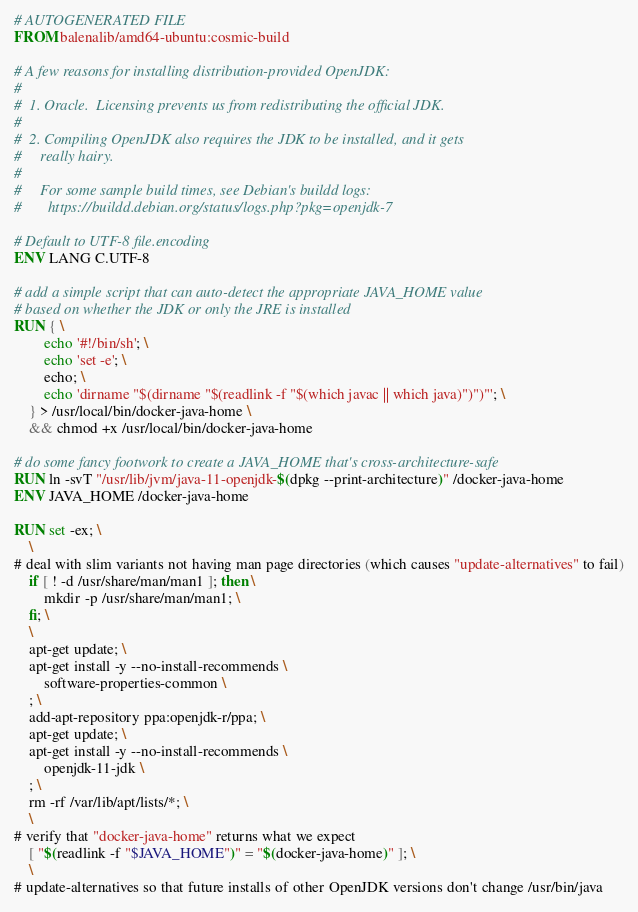<code> <loc_0><loc_0><loc_500><loc_500><_Dockerfile_># AUTOGENERATED FILE
FROM balenalib/amd64-ubuntu:cosmic-build

# A few reasons for installing distribution-provided OpenJDK:
#
#  1. Oracle.  Licensing prevents us from redistributing the official JDK.
#
#  2. Compiling OpenJDK also requires the JDK to be installed, and it gets
#     really hairy.
#
#     For some sample build times, see Debian's buildd logs:
#       https://buildd.debian.org/status/logs.php?pkg=openjdk-7

# Default to UTF-8 file.encoding
ENV LANG C.UTF-8

# add a simple script that can auto-detect the appropriate JAVA_HOME value
# based on whether the JDK or only the JRE is installed
RUN { \
		echo '#!/bin/sh'; \
		echo 'set -e'; \
		echo; \
		echo 'dirname "$(dirname "$(readlink -f "$(which javac || which java)")")"'; \
	} > /usr/local/bin/docker-java-home \
	&& chmod +x /usr/local/bin/docker-java-home

# do some fancy footwork to create a JAVA_HOME that's cross-architecture-safe
RUN ln -svT "/usr/lib/jvm/java-11-openjdk-$(dpkg --print-architecture)" /docker-java-home
ENV JAVA_HOME /docker-java-home

RUN set -ex; \
	\
# deal with slim variants not having man page directories (which causes "update-alternatives" to fail)
	if [ ! -d /usr/share/man/man1 ]; then \
		mkdir -p /usr/share/man/man1; \
	fi; \
	\
	apt-get update; \
	apt-get install -y --no-install-recommends \
		software-properties-common \
	; \
	add-apt-repository ppa:openjdk-r/ppa; \
	apt-get update; \
	apt-get install -y --no-install-recommends \
		openjdk-11-jdk \
	; \
	rm -rf /var/lib/apt/lists/*; \
	\
# verify that "docker-java-home" returns what we expect
	[ "$(readlink -f "$JAVA_HOME")" = "$(docker-java-home)" ]; \
	\
# update-alternatives so that future installs of other OpenJDK versions don't change /usr/bin/java</code> 